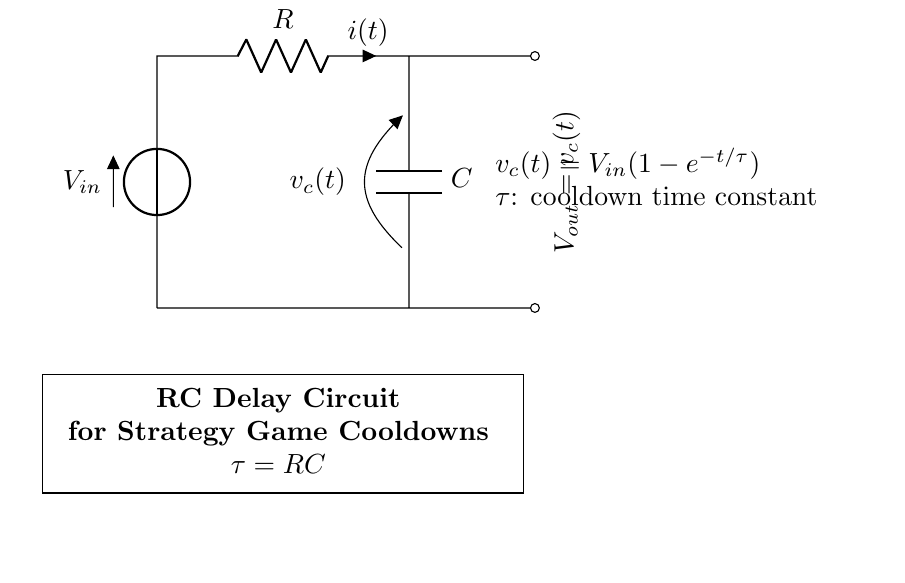What is the input voltage in the diagram? The input voltage is denoted as V_in in the circuit. It is located at the top-left corner and is the voltage source provided to the circuit.
Answer: V_in What does the variable v_c(t) represent? v_c(t) is the voltage across the capacitor as a function of time. It is indicated in the circuit diagram and describes how the voltage changes as the capacitor charges.
Answer: v_c(t) What is the time constant τ (tau) for this circuit? The time constant τ (tau) is defined as the product of the resistance R and the capacitance C in the circuit. It indicates how quickly the circuit responds to changes.
Answer: RC How does the output voltage V_out relate to the capacitor voltage? The output voltage V_out is equal to the voltage across the capacitor, represented as v_c(t) in the diagram. Therefore, V_out and v_c(t) are the same variable in this circuit.
Answer: v_c(t) If the resistor value is doubled, what happens to the time constant τ? When the resistor value R is doubled, the time constant τ increases because τ is directly proportional to the resistance. Thus, the time constant becomes 2RC.
Answer: 2RC What is the equation that describes the voltage across the capacitor over time? The equation for the voltage across the capacitor is given as v_c(t) = V_in(1 - e^{-t/τ}). This describes how the capacitor voltage builds up over time as it charges.
Answer: v_c(t) = V_in(1 - e^{-t/τ}) What effect does increasing the capacitance C have on the charging time of the capacitor? Increasing the capacitance C extends the charging time of the capacitor because a larger capacitance results in a greater time constant τ (τ = RC), causing the capacitor to take longer to charge to the input voltage.
Answer: Longer charging time 